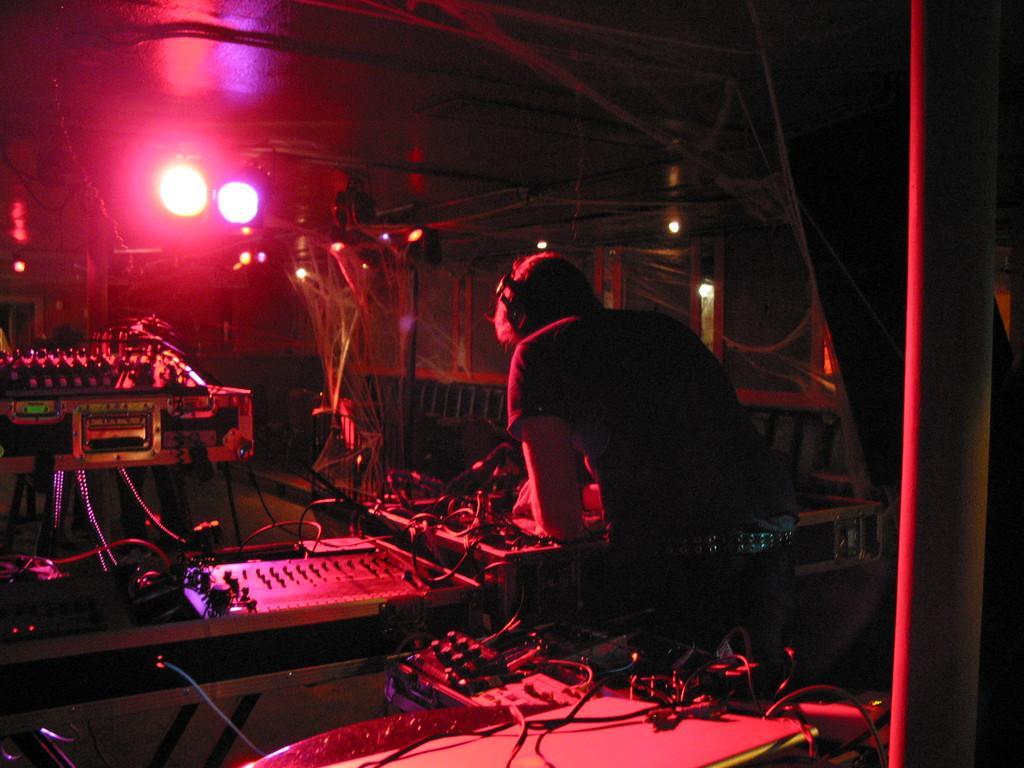Could you give a brief overview of what you see in this image? In the image we can see a person standing, wearing clothes and headsets. Here we can see cable wires and lights. We can even see there are electronic device. 